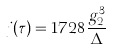<formula> <loc_0><loc_0><loc_500><loc_500>j ( \tau ) = 1 7 2 8 \frac { g _ { 2 } ^ { 3 } } { \Delta }</formula> 